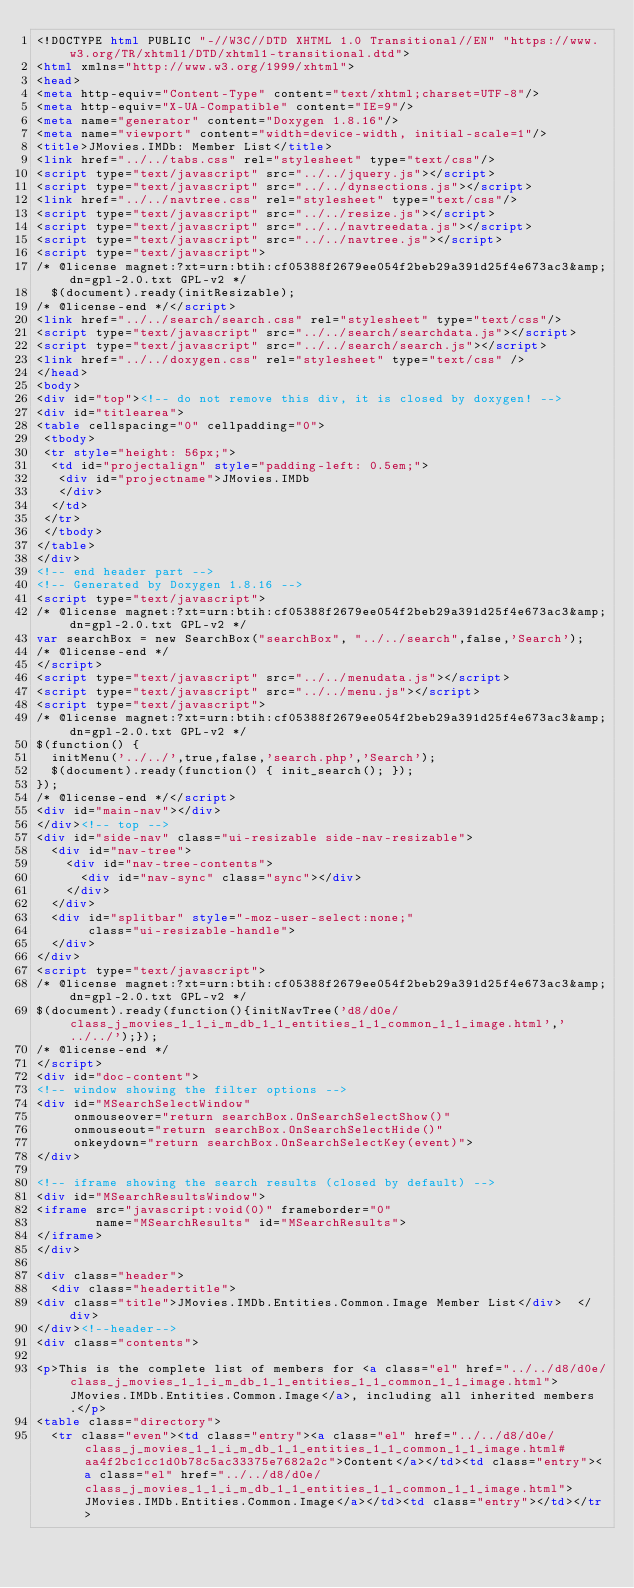Convert code to text. <code><loc_0><loc_0><loc_500><loc_500><_HTML_><!DOCTYPE html PUBLIC "-//W3C//DTD XHTML 1.0 Transitional//EN" "https://www.w3.org/TR/xhtml1/DTD/xhtml1-transitional.dtd">
<html xmlns="http://www.w3.org/1999/xhtml">
<head>
<meta http-equiv="Content-Type" content="text/xhtml;charset=UTF-8"/>
<meta http-equiv="X-UA-Compatible" content="IE=9"/>
<meta name="generator" content="Doxygen 1.8.16"/>
<meta name="viewport" content="width=device-width, initial-scale=1"/>
<title>JMovies.IMDb: Member List</title>
<link href="../../tabs.css" rel="stylesheet" type="text/css"/>
<script type="text/javascript" src="../../jquery.js"></script>
<script type="text/javascript" src="../../dynsections.js"></script>
<link href="../../navtree.css" rel="stylesheet" type="text/css"/>
<script type="text/javascript" src="../../resize.js"></script>
<script type="text/javascript" src="../../navtreedata.js"></script>
<script type="text/javascript" src="../../navtree.js"></script>
<script type="text/javascript">
/* @license magnet:?xt=urn:btih:cf05388f2679ee054f2beb29a391d25f4e673ac3&amp;dn=gpl-2.0.txt GPL-v2 */
  $(document).ready(initResizable);
/* @license-end */</script>
<link href="../../search/search.css" rel="stylesheet" type="text/css"/>
<script type="text/javascript" src="../../search/searchdata.js"></script>
<script type="text/javascript" src="../../search/search.js"></script>
<link href="../../doxygen.css" rel="stylesheet" type="text/css" />
</head>
<body>
<div id="top"><!-- do not remove this div, it is closed by doxygen! -->
<div id="titlearea">
<table cellspacing="0" cellpadding="0">
 <tbody>
 <tr style="height: 56px;">
  <td id="projectalign" style="padding-left: 0.5em;">
   <div id="projectname">JMovies.IMDb
   </div>
  </td>
 </tr>
 </tbody>
</table>
</div>
<!-- end header part -->
<!-- Generated by Doxygen 1.8.16 -->
<script type="text/javascript">
/* @license magnet:?xt=urn:btih:cf05388f2679ee054f2beb29a391d25f4e673ac3&amp;dn=gpl-2.0.txt GPL-v2 */
var searchBox = new SearchBox("searchBox", "../../search",false,'Search');
/* @license-end */
</script>
<script type="text/javascript" src="../../menudata.js"></script>
<script type="text/javascript" src="../../menu.js"></script>
<script type="text/javascript">
/* @license magnet:?xt=urn:btih:cf05388f2679ee054f2beb29a391d25f4e673ac3&amp;dn=gpl-2.0.txt GPL-v2 */
$(function() {
  initMenu('../../',true,false,'search.php','Search');
  $(document).ready(function() { init_search(); });
});
/* @license-end */</script>
<div id="main-nav"></div>
</div><!-- top -->
<div id="side-nav" class="ui-resizable side-nav-resizable">
  <div id="nav-tree">
    <div id="nav-tree-contents">
      <div id="nav-sync" class="sync"></div>
    </div>
  </div>
  <div id="splitbar" style="-moz-user-select:none;" 
       class="ui-resizable-handle">
  </div>
</div>
<script type="text/javascript">
/* @license magnet:?xt=urn:btih:cf05388f2679ee054f2beb29a391d25f4e673ac3&amp;dn=gpl-2.0.txt GPL-v2 */
$(document).ready(function(){initNavTree('d8/d0e/class_j_movies_1_1_i_m_db_1_1_entities_1_1_common_1_1_image.html','../../');});
/* @license-end */
</script>
<div id="doc-content">
<!-- window showing the filter options -->
<div id="MSearchSelectWindow"
     onmouseover="return searchBox.OnSearchSelectShow()"
     onmouseout="return searchBox.OnSearchSelectHide()"
     onkeydown="return searchBox.OnSearchSelectKey(event)">
</div>

<!-- iframe showing the search results (closed by default) -->
<div id="MSearchResultsWindow">
<iframe src="javascript:void(0)" frameborder="0" 
        name="MSearchResults" id="MSearchResults">
</iframe>
</div>

<div class="header">
  <div class="headertitle">
<div class="title">JMovies.IMDb.Entities.Common.Image Member List</div>  </div>
</div><!--header-->
<div class="contents">

<p>This is the complete list of members for <a class="el" href="../../d8/d0e/class_j_movies_1_1_i_m_db_1_1_entities_1_1_common_1_1_image.html">JMovies.IMDb.Entities.Common.Image</a>, including all inherited members.</p>
<table class="directory">
  <tr class="even"><td class="entry"><a class="el" href="../../d8/d0e/class_j_movies_1_1_i_m_db_1_1_entities_1_1_common_1_1_image.html#aa4f2bc1cc1d0b78c5ac33375e7682a2c">Content</a></td><td class="entry"><a class="el" href="../../d8/d0e/class_j_movies_1_1_i_m_db_1_1_entities_1_1_common_1_1_image.html">JMovies.IMDb.Entities.Common.Image</a></td><td class="entry"></td></tr></code> 